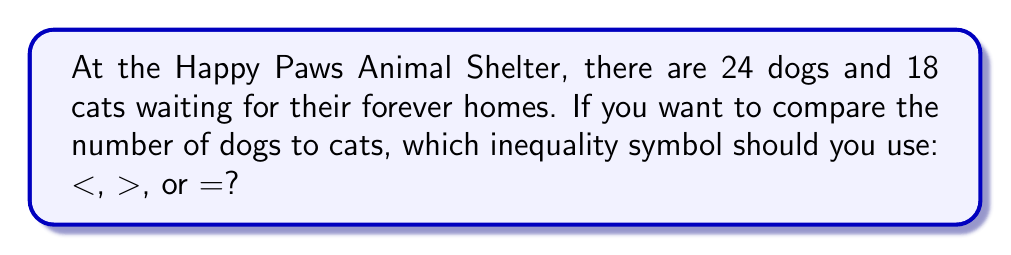Can you solve this math problem? Let's approach this step-by-step:

1. We need to compare the number of dogs to the number of cats.
   - Number of dogs = 24
   - Number of cats = 18

2. To compare these numbers, we can set up an inequality:
   $24 \text{ } ? \text{ } 18$

3. Now, let's think about which number is bigger:
   - 24 is greater than 18
   - We can verify this by subtracting: $24 - 18 = 6$
   - Since the result is positive, 24 is indeed greater than 18

4. Therefore, we should use the "greater than" symbol: $>$

5. The correct inequality is:
   $24 > 18$

This means there are more dogs than cats at the Happy Paws Animal Shelter.
Answer: $>$ 